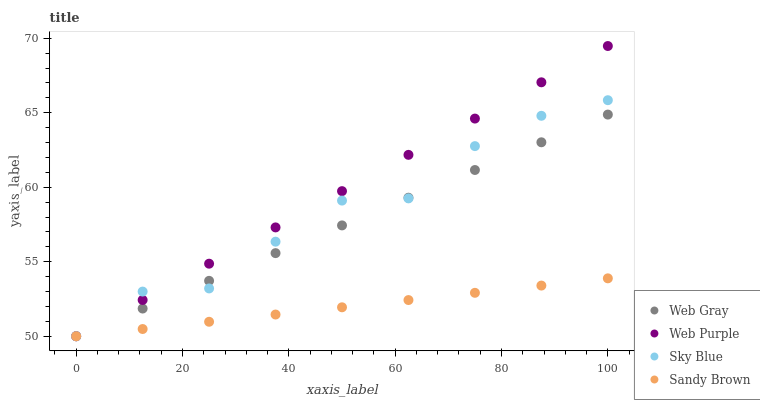Does Sandy Brown have the minimum area under the curve?
Answer yes or no. Yes. Does Web Purple have the maximum area under the curve?
Answer yes or no. Yes. Does Web Gray have the minimum area under the curve?
Answer yes or no. No. Does Web Gray have the maximum area under the curve?
Answer yes or no. No. Is Web Gray the smoothest?
Answer yes or no. Yes. Is Sky Blue the roughest?
Answer yes or no. Yes. Is Web Purple the smoothest?
Answer yes or no. No. Is Web Purple the roughest?
Answer yes or no. No. Does Sky Blue have the lowest value?
Answer yes or no. Yes. Does Web Purple have the highest value?
Answer yes or no. Yes. Does Web Gray have the highest value?
Answer yes or no. No. Does Web Gray intersect Sandy Brown?
Answer yes or no. Yes. Is Web Gray less than Sandy Brown?
Answer yes or no. No. Is Web Gray greater than Sandy Brown?
Answer yes or no. No. 